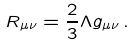<formula> <loc_0><loc_0><loc_500><loc_500>R _ { \mu \nu } = \frac { 2 } { 3 } \Lambda g _ { \mu \nu } \, .</formula> 